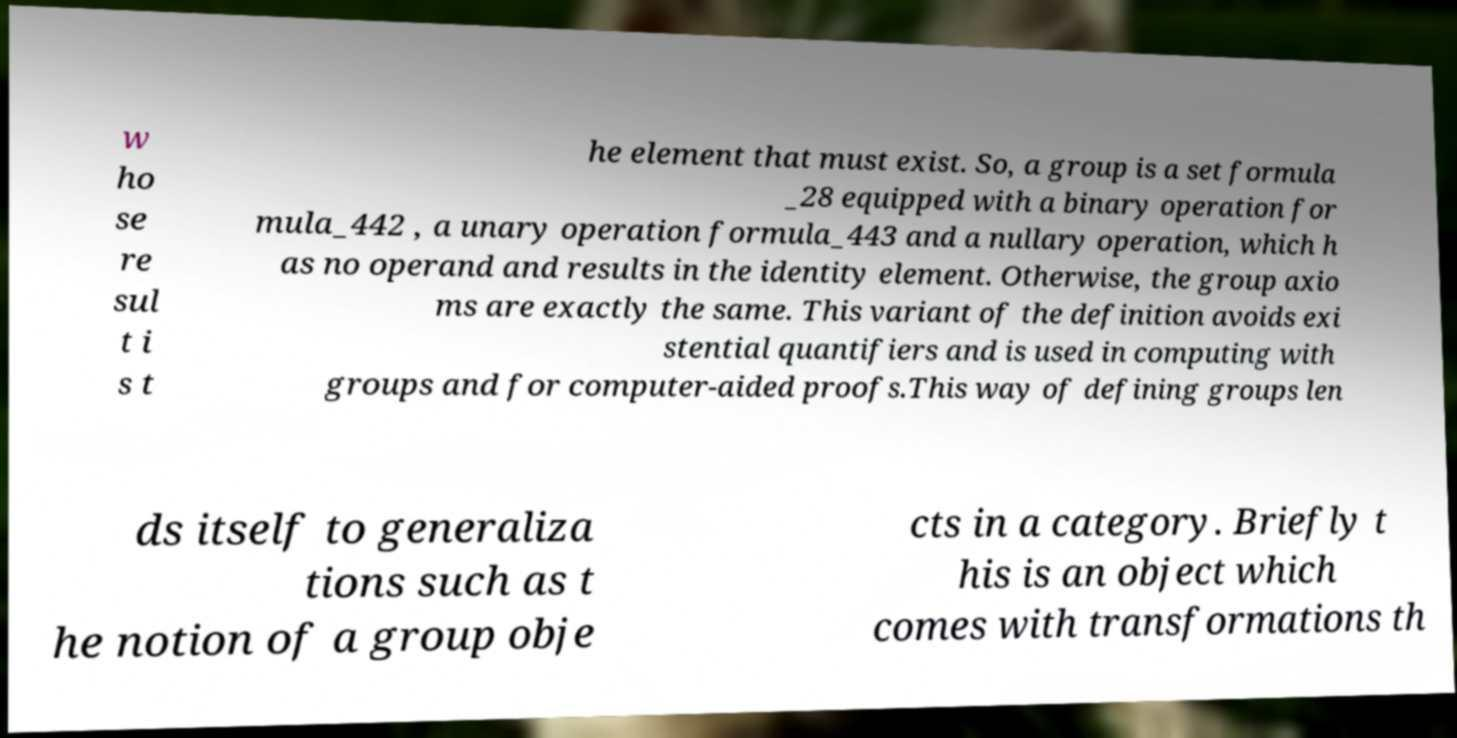What messages or text are displayed in this image? I need them in a readable, typed format. w ho se re sul t i s t he element that must exist. So, a group is a set formula _28 equipped with a binary operation for mula_442 , a unary operation formula_443 and a nullary operation, which h as no operand and results in the identity element. Otherwise, the group axio ms are exactly the same. This variant of the definition avoids exi stential quantifiers and is used in computing with groups and for computer-aided proofs.This way of defining groups len ds itself to generaliza tions such as t he notion of a group obje cts in a category. Briefly t his is an object which comes with transformations th 